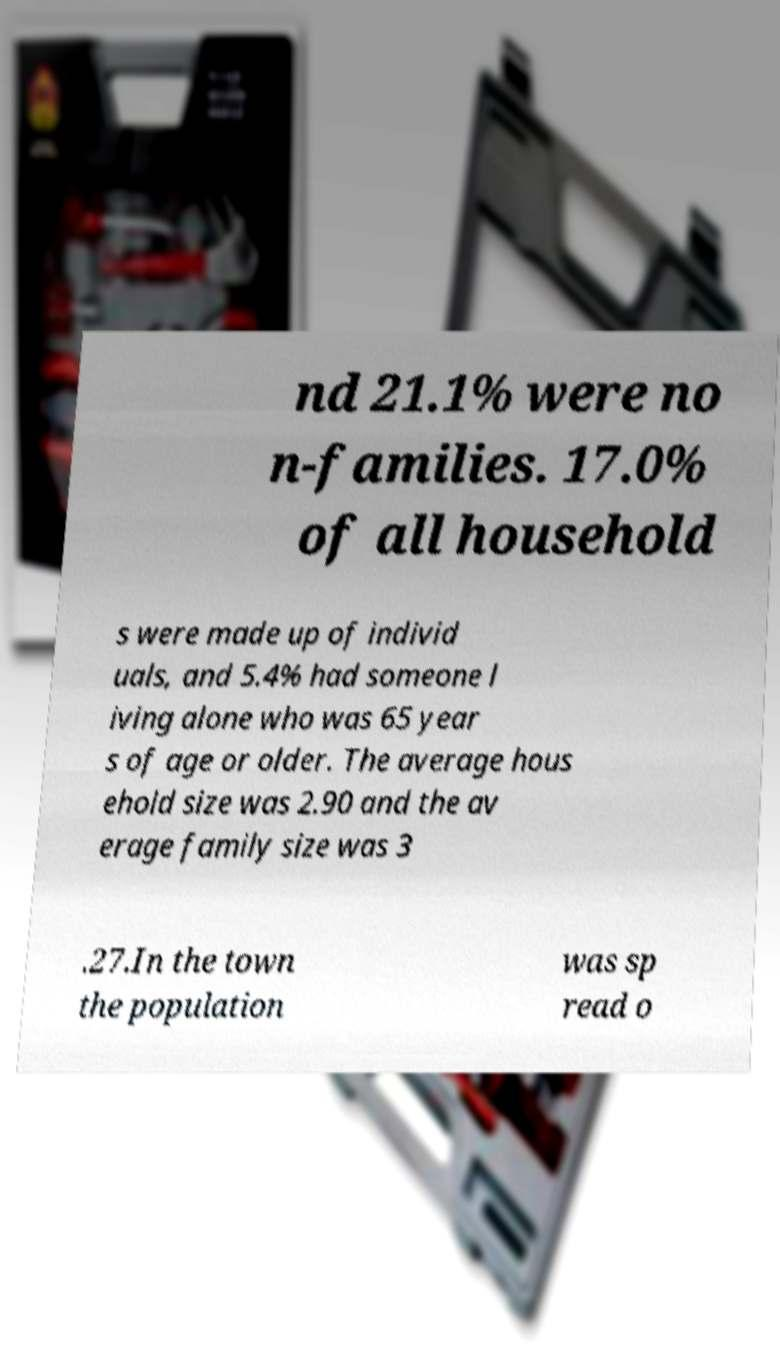Please read and relay the text visible in this image. What does it say? nd 21.1% were no n-families. 17.0% of all household s were made up of individ uals, and 5.4% had someone l iving alone who was 65 year s of age or older. The average hous ehold size was 2.90 and the av erage family size was 3 .27.In the town the population was sp read o 